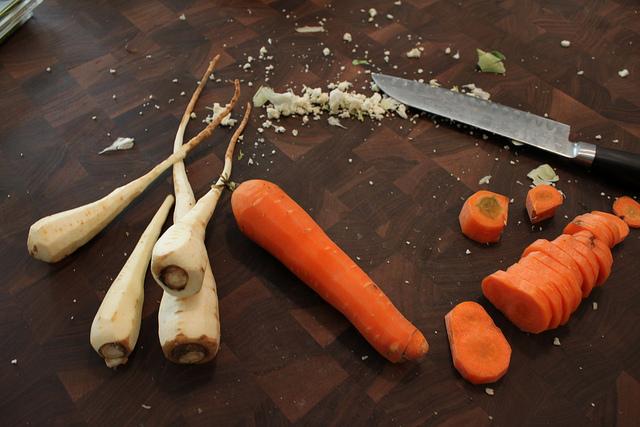What is the white vegetable called?
Concise answer only. Parsnip. Which vegetable has been cut up?
Quick response, please. Carrot. What color is the handle on the knife?
Keep it brief. Black. 